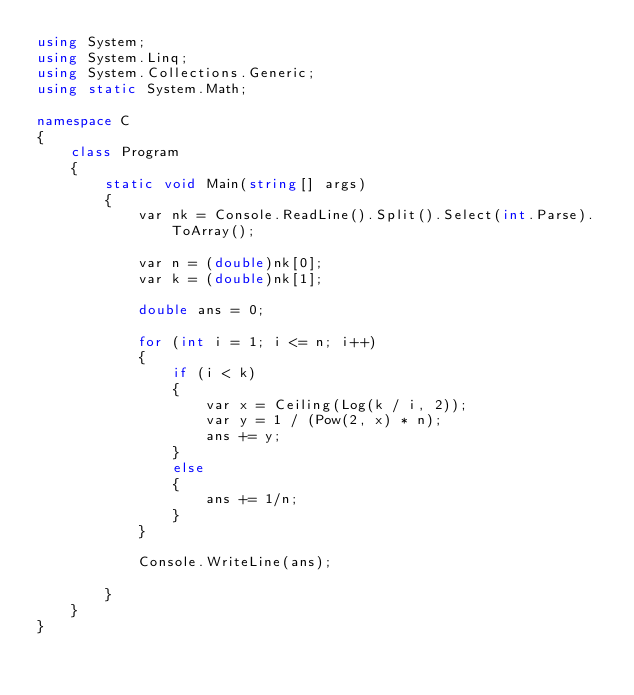<code> <loc_0><loc_0><loc_500><loc_500><_C#_>using System;
using System.Linq;
using System.Collections.Generic;
using static System.Math;

namespace C
{
    class Program
    {
        static void Main(string[] args)
        {
            var nk = Console.ReadLine().Split().Select(int.Parse).ToArray();

            var n = (double)nk[0];
            var k = (double)nk[1];

            double ans = 0;

            for (int i = 1; i <= n; i++)
            {
                if (i < k)
                {
                    var x = Ceiling(Log(k / i, 2));
                    var y = 1 / (Pow(2, x) * n);
                    ans += y;
                }
                else
                {
                    ans += 1/n;
                }
            }

            Console.WriteLine(ans);

        }
    }
}
</code> 